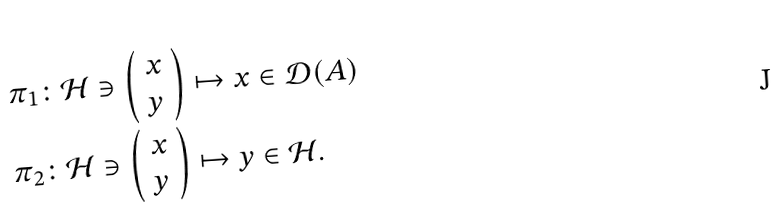<formula> <loc_0><loc_0><loc_500><loc_500>& \pi _ { 1 } \colon \mathcal { H } \ni \left ( \begin{array} { c } x \\ y \end{array} \right ) \mapsto x \in \mathcal { D } ( A ) \\ & \pi _ { 2 } \colon \mathcal { H } \ni \left ( \begin{array} { c } x \\ y \end{array} \right ) \mapsto y \in \mathcal { H } .</formula> 